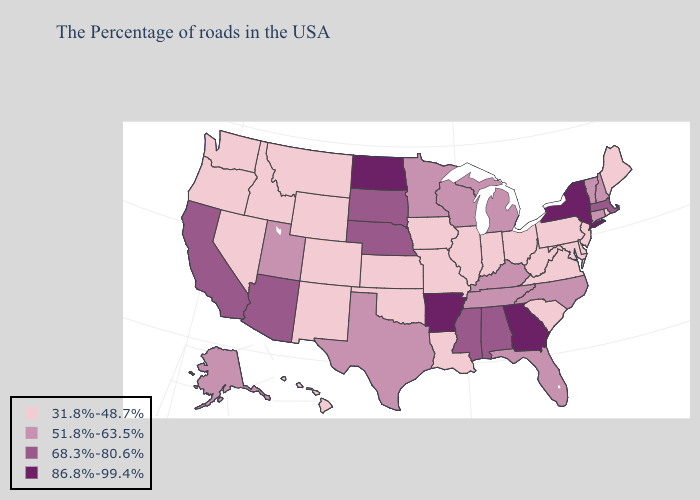Name the states that have a value in the range 68.3%-80.6%?
Short answer required. Massachusetts, Alabama, Mississippi, Nebraska, South Dakota, Arizona, California. Name the states that have a value in the range 51.8%-63.5%?
Keep it brief. New Hampshire, Vermont, Connecticut, North Carolina, Florida, Michigan, Kentucky, Tennessee, Wisconsin, Minnesota, Texas, Utah, Alaska. Does Oregon have a higher value than Michigan?
Concise answer only. No. What is the value of Alabama?
Keep it brief. 68.3%-80.6%. What is the value of South Carolina?
Give a very brief answer. 31.8%-48.7%. What is the value of Texas?
Write a very short answer. 51.8%-63.5%. Among the states that border New Jersey , does Pennsylvania have the lowest value?
Short answer required. Yes. Does Hawaii have a lower value than Nevada?
Give a very brief answer. No. Which states have the lowest value in the West?
Quick response, please. Wyoming, Colorado, New Mexico, Montana, Idaho, Nevada, Washington, Oregon, Hawaii. Does the first symbol in the legend represent the smallest category?
Answer briefly. Yes. Does Louisiana have the lowest value in the USA?
Concise answer only. Yes. Name the states that have a value in the range 86.8%-99.4%?
Keep it brief. New York, Georgia, Arkansas, North Dakota. What is the highest value in states that border Virginia?
Keep it brief. 51.8%-63.5%. Name the states that have a value in the range 68.3%-80.6%?
Short answer required. Massachusetts, Alabama, Mississippi, Nebraska, South Dakota, Arizona, California. 